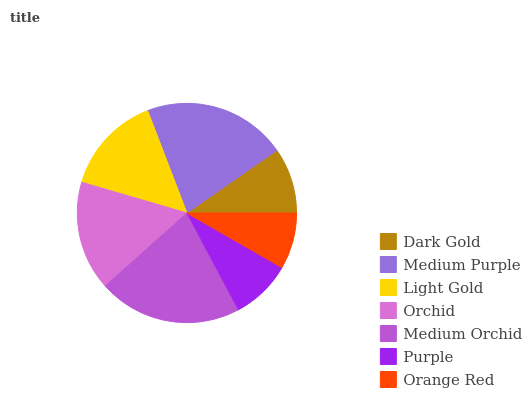Is Orange Red the minimum?
Answer yes or no. Yes. Is Medium Orchid the maximum?
Answer yes or no. Yes. Is Medium Purple the minimum?
Answer yes or no. No. Is Medium Purple the maximum?
Answer yes or no. No. Is Medium Purple greater than Dark Gold?
Answer yes or no. Yes. Is Dark Gold less than Medium Purple?
Answer yes or no. Yes. Is Dark Gold greater than Medium Purple?
Answer yes or no. No. Is Medium Purple less than Dark Gold?
Answer yes or no. No. Is Light Gold the high median?
Answer yes or no. Yes. Is Light Gold the low median?
Answer yes or no. Yes. Is Dark Gold the high median?
Answer yes or no. No. Is Purple the low median?
Answer yes or no. No. 